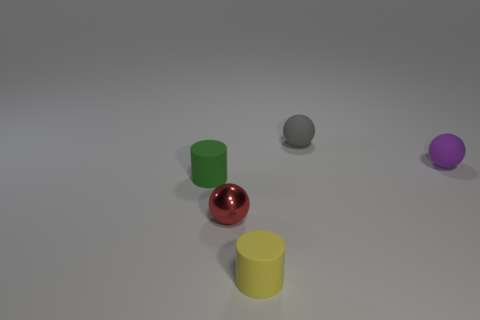Is the yellow object made of the same material as the green cylinder?
Your response must be concise. Yes. How many things are either tiny purple balls or tiny blue cubes?
Ensure brevity in your answer.  1. The thing that is in front of the metallic ball has what shape?
Your response must be concise. Cylinder. The cylinder that is the same material as the tiny green thing is what color?
Provide a succinct answer. Yellow. There is a yellow object that is the same shape as the tiny green thing; what is it made of?
Keep it short and to the point. Rubber. The small yellow object has what shape?
Give a very brief answer. Cylinder. The small object that is both on the right side of the red thing and in front of the tiny green matte cylinder is made of what material?
Your answer should be very brief. Rubber. What shape is the tiny green thing that is the same material as the gray ball?
Your answer should be compact. Cylinder. There is a small object that is both in front of the tiny purple object and behind the tiny red ball; what shape is it?
Give a very brief answer. Cylinder. What number of other objects are the same color as the metal thing?
Make the answer very short. 0. 